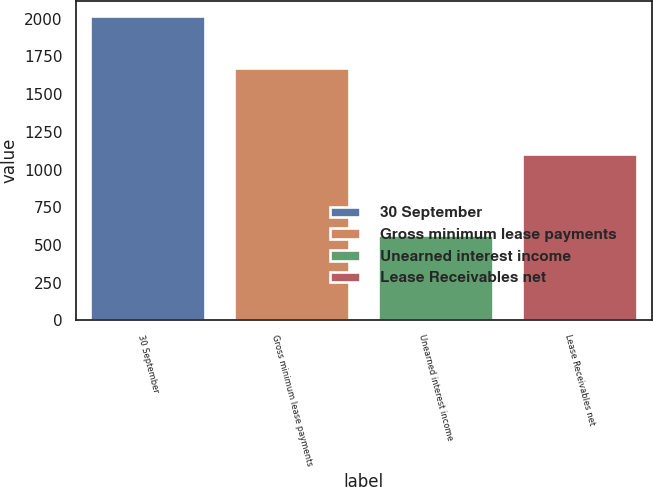Convert chart to OTSL. <chart><loc_0><loc_0><loc_500><loc_500><bar_chart><fcel>30 September<fcel>Gross minimum lease payments<fcel>Unearned interest income<fcel>Lease Receivables net<nl><fcel>2018<fcel>1673.7<fcel>568.3<fcel>1105.4<nl></chart> 